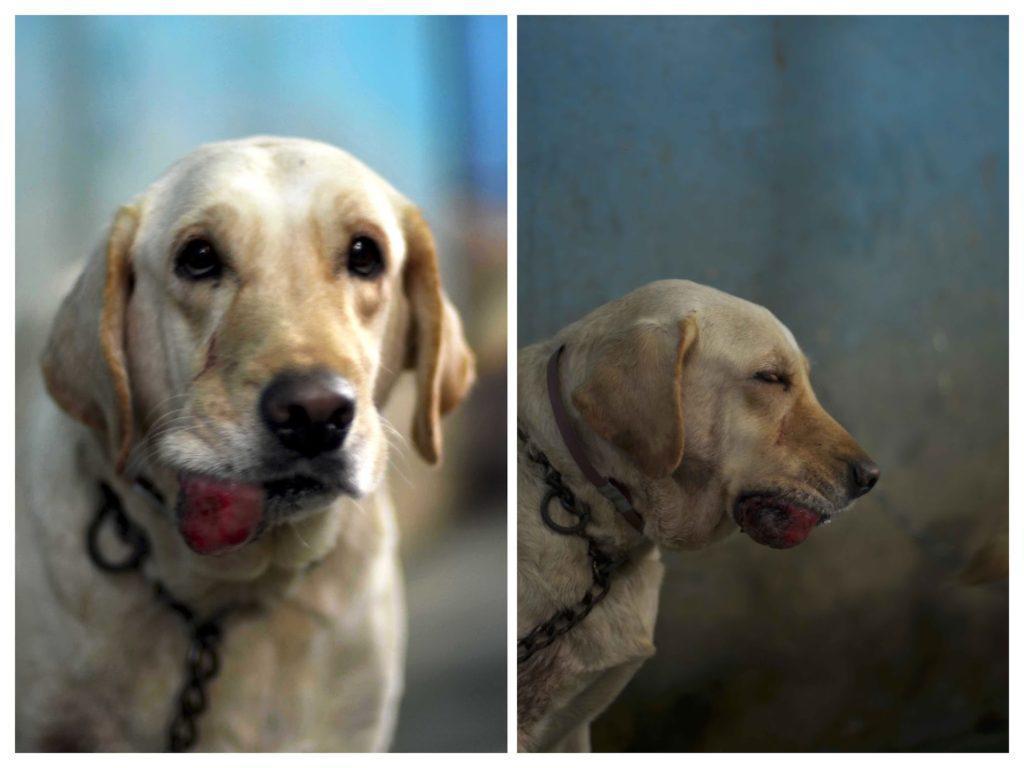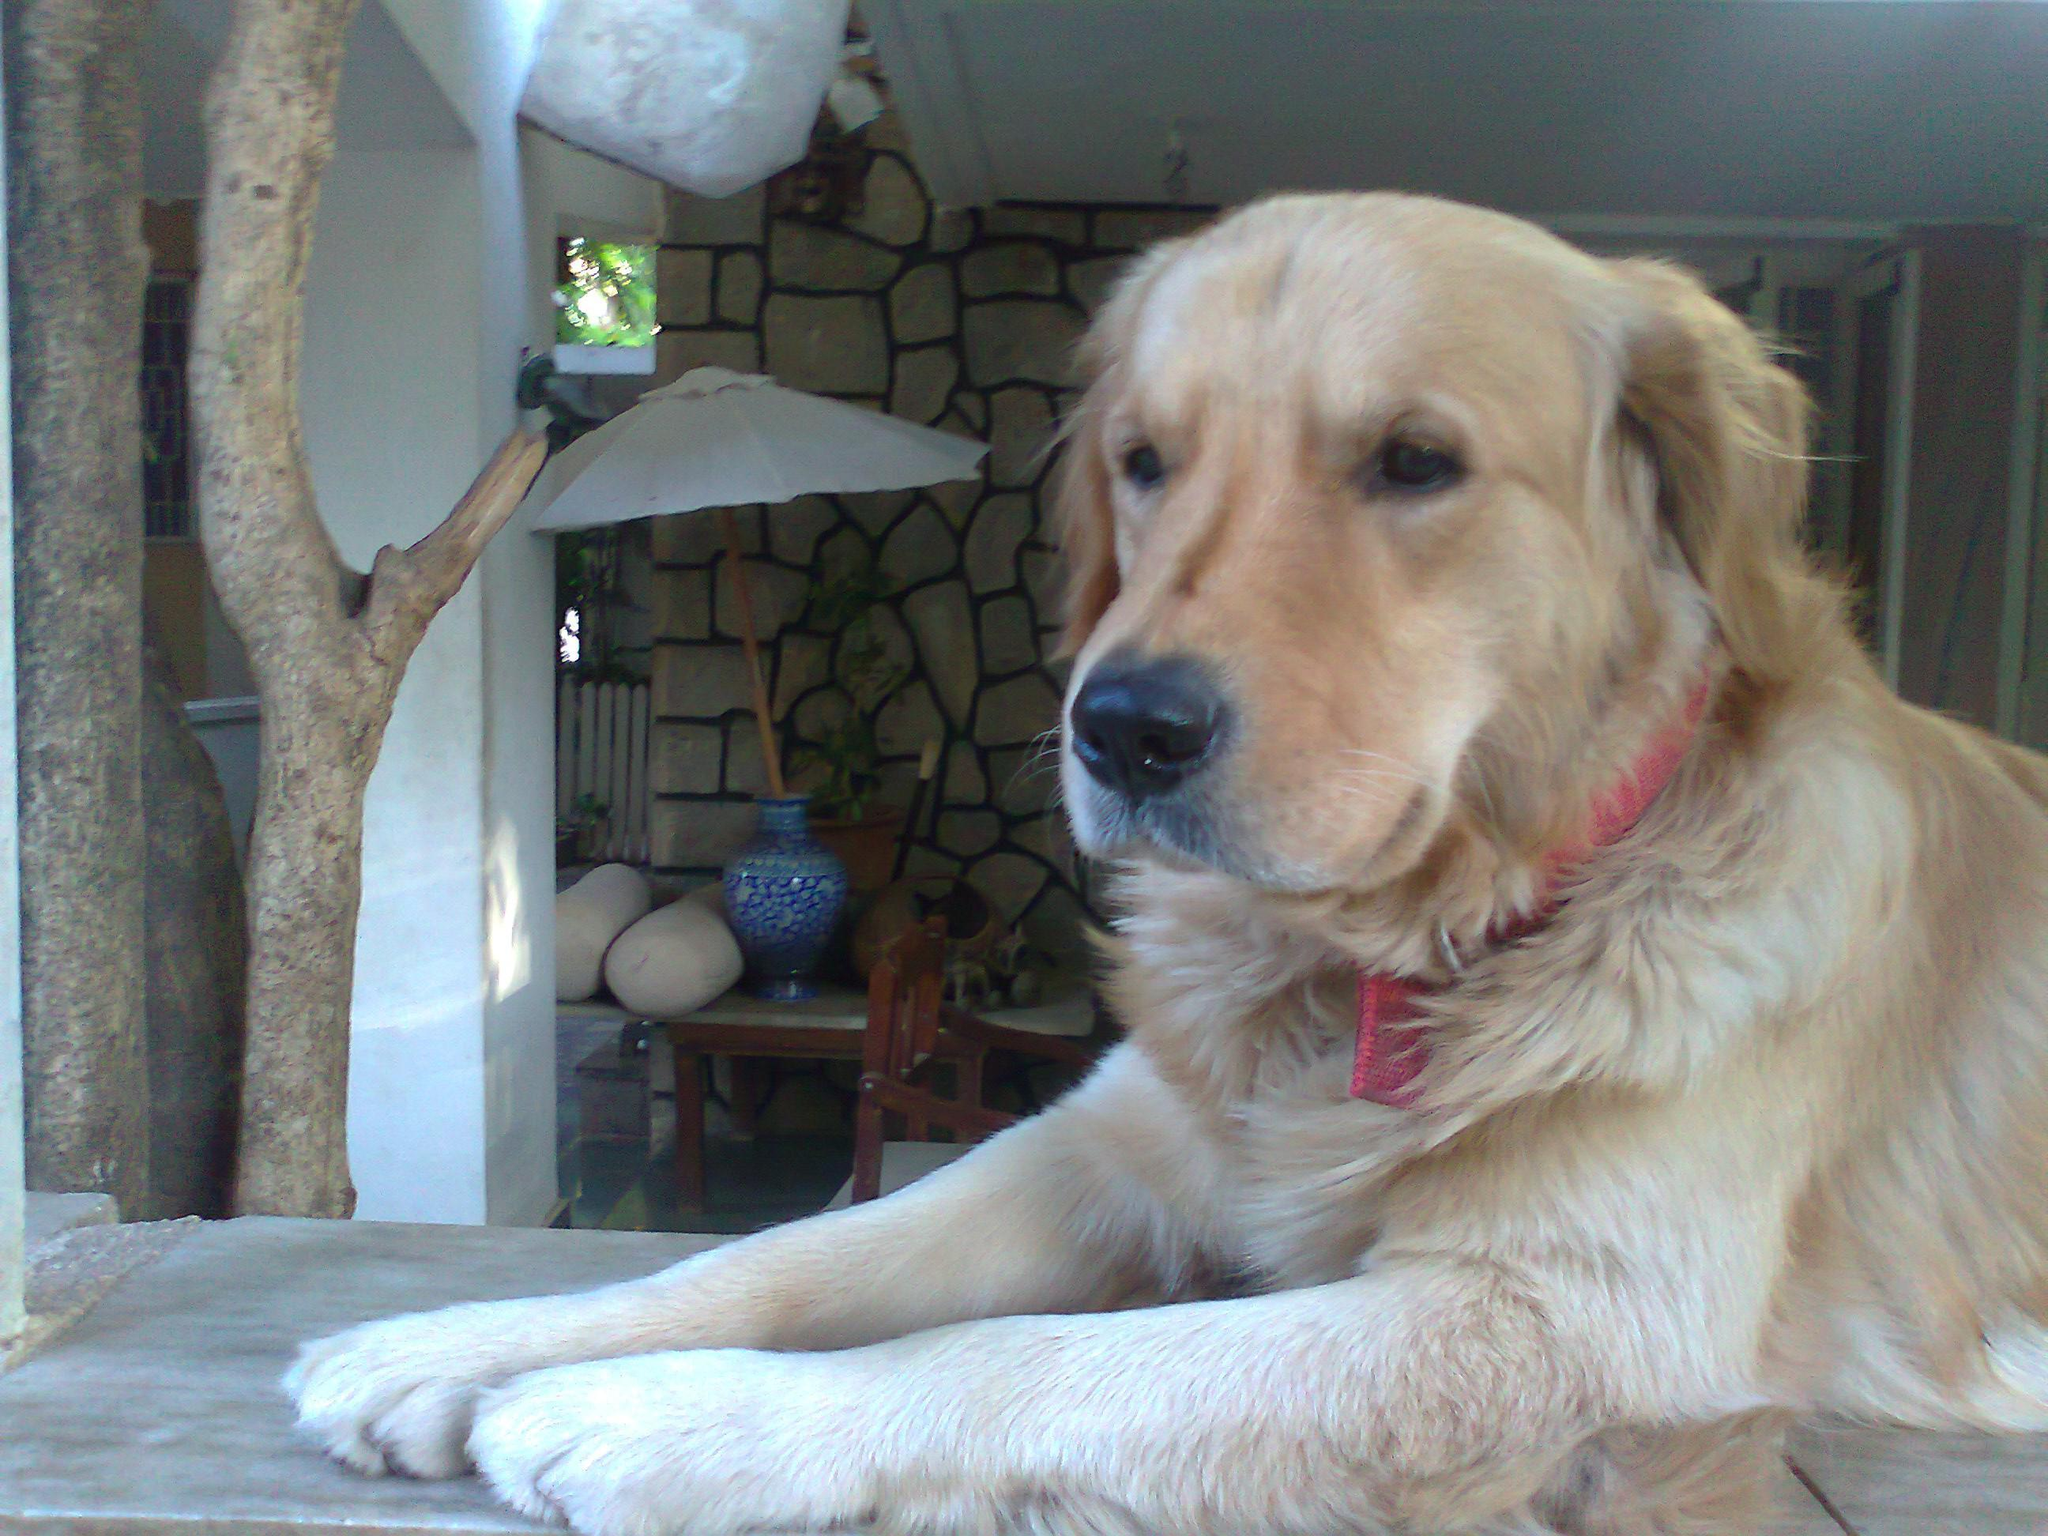The first image is the image on the left, the second image is the image on the right. Given the left and right images, does the statement "The right image contains one or more black labs." hold true? Answer yes or no. No. The first image is the image on the left, the second image is the image on the right. Analyze the images presented: Is the assertion "An image shows one reclining dog, which is wearing a collar." valid? Answer yes or no. Yes. 